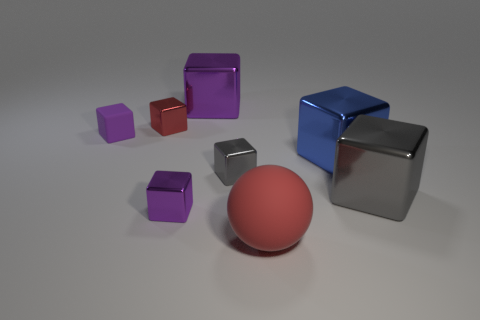How many purple blocks must be subtracted to get 2 purple blocks? 1 Subtract all blocks. How many objects are left? 1 Subtract 5 blocks. How many blocks are left? 2 Subtract all blue cubes. Subtract all red cylinders. How many cubes are left? 6 Subtract all green spheres. How many gray cubes are left? 2 Subtract all tiny objects. Subtract all large purple metal objects. How many objects are left? 3 Add 7 blue objects. How many blue objects are left? 8 Add 8 red metallic things. How many red metallic things exist? 9 Add 1 gray metal blocks. How many objects exist? 9 Subtract all gray cubes. How many cubes are left? 5 